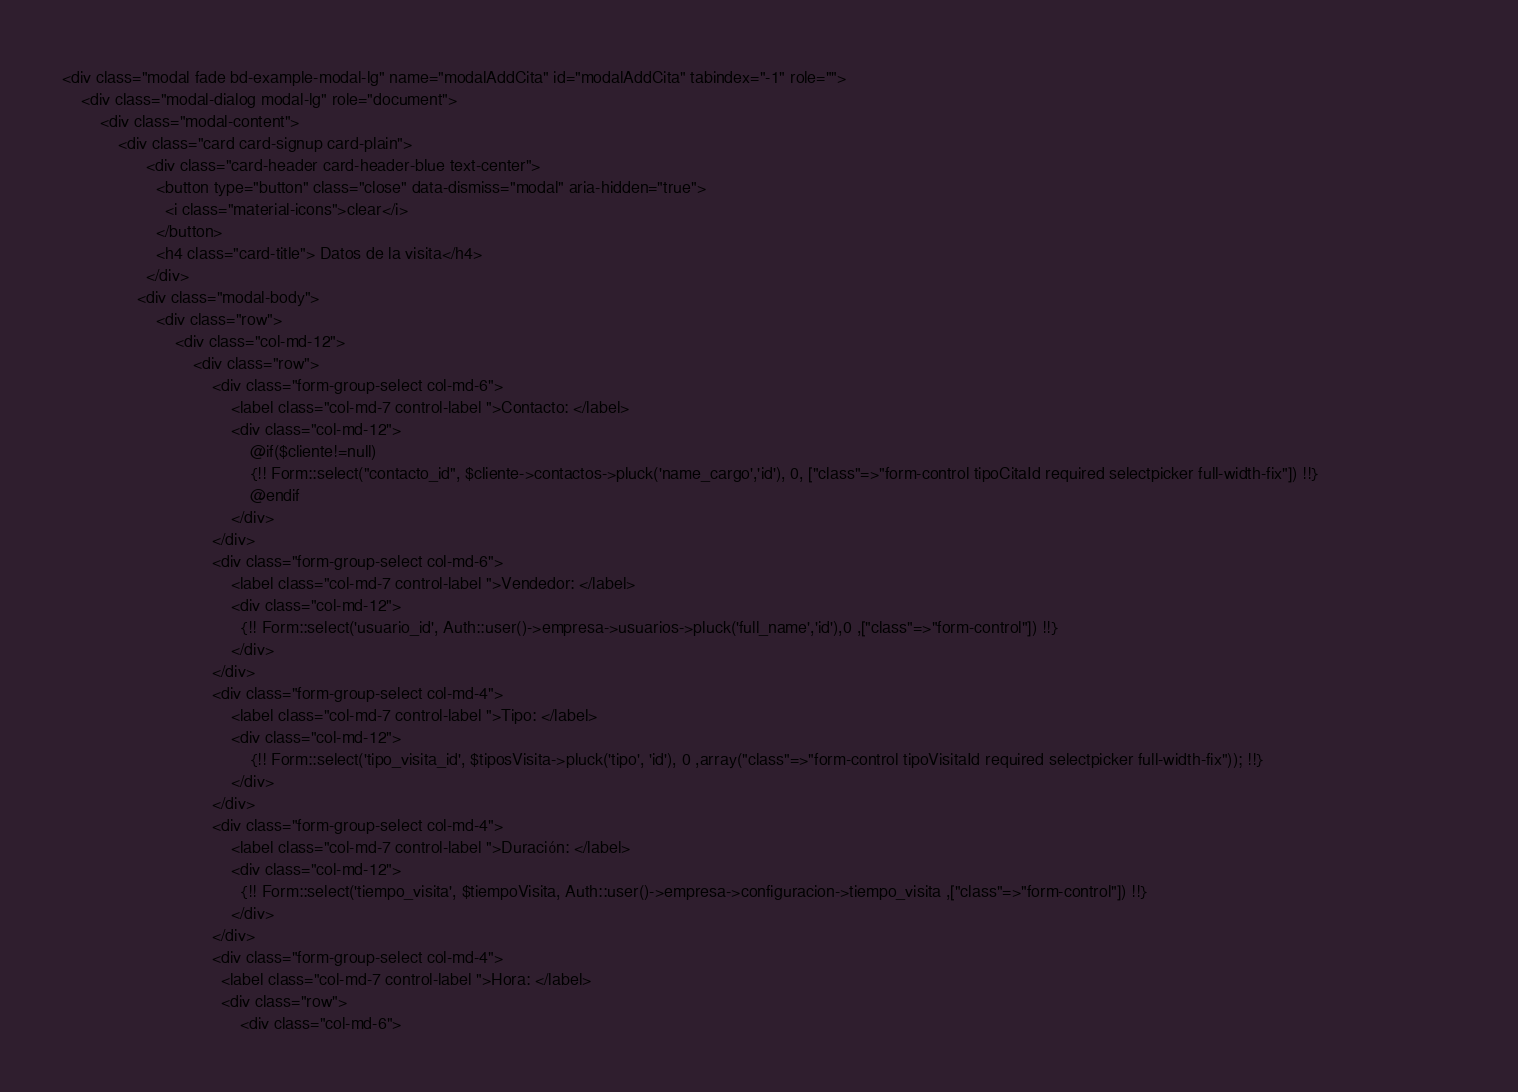<code> <loc_0><loc_0><loc_500><loc_500><_PHP_><div class="modal fade bd-example-modal-lg" name="modalAddCita" id="modalAddCita" tabindex="-1" role="">
    <div class="modal-dialog modal-lg" role="document">
        <div class="modal-content">
            <div class="card card-signup card-plain"> 
                  <div class="card-header card-header-blue text-center">
                    <button type="button" class="close" data-dismiss="modal" aria-hidden="true">   
                      <i class="material-icons">clear</i>
                    </button>
                    <h4 class="card-title"> Datos de la visita</h4> 
                  </div>
                <div class="modal-body">
                    <div class="row">
                        <div class="col-md-12">
                            <div class="row">
                                <div class="form-group-select col-md-6">
                                    <label class="col-md-7 control-label ">Contacto: </label>
                                    <div class="col-md-12">
                                        @if($cliente!=null)
                                        {!! Form::select("contacto_id", $cliente->contactos->pluck('name_cargo','id'), 0, ["class"=>"form-control tipoCitaId required selectpicker full-width-fix"]) !!}
                                        @endif
                                    </div>
                                </div>
                                <div class="form-group-select col-md-6">
                                    <label class="col-md-7 control-label ">Vendedor: </label>
                                    <div class="col-md-12">
                                      {!! Form::select('usuario_id', Auth::user()->empresa->usuarios->pluck('full_name','id'),0 ,["class"=>"form-control"]) !!}
                                    </div>
                                </div>
                                <div class="form-group-select col-md-4">
                                    <label class="col-md-7 control-label ">Tipo: </label>
                                    <div class="col-md-12">
                                        {!! Form::select('tipo_visita_id', $tiposVisita->pluck('tipo', 'id'), 0 ,array("class"=>"form-control tipoVisitaId required selectpicker full-width-fix")); !!}                                         
                                    </div>
                                </div>
                                <div class="form-group-select col-md-4">
                                    <label class="col-md-7 control-label ">Duración: </label>
                                    <div class="col-md-12">
                                      {!! Form::select('tiempo_visita', $tiempoVisita, Auth::user()->empresa->configuracion->tiempo_visita ,["class"=>"form-control"]) !!}
                                    </div>
                                </div>
                                <div class="form-group-select col-md-4">
                                  <label class="col-md-7 control-label ">Hora: </label>
                                  <div class="row">
                                      <div class="col-md-6"></code> 